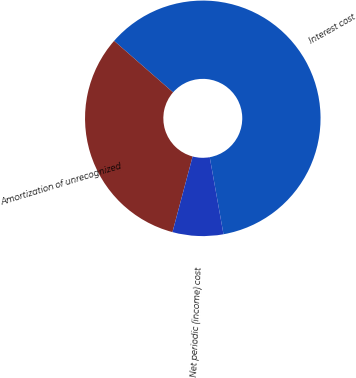<chart> <loc_0><loc_0><loc_500><loc_500><pie_chart><fcel>Interest cost<fcel>Amortization of unrecognized<fcel>Net periodic (income) cost<nl><fcel>60.76%<fcel>32.28%<fcel>6.96%<nl></chart> 